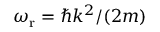Convert formula to latex. <formula><loc_0><loc_0><loc_500><loc_500>\omega _ { r } = \hbar { k } ^ { 2 } / ( 2 m )</formula> 